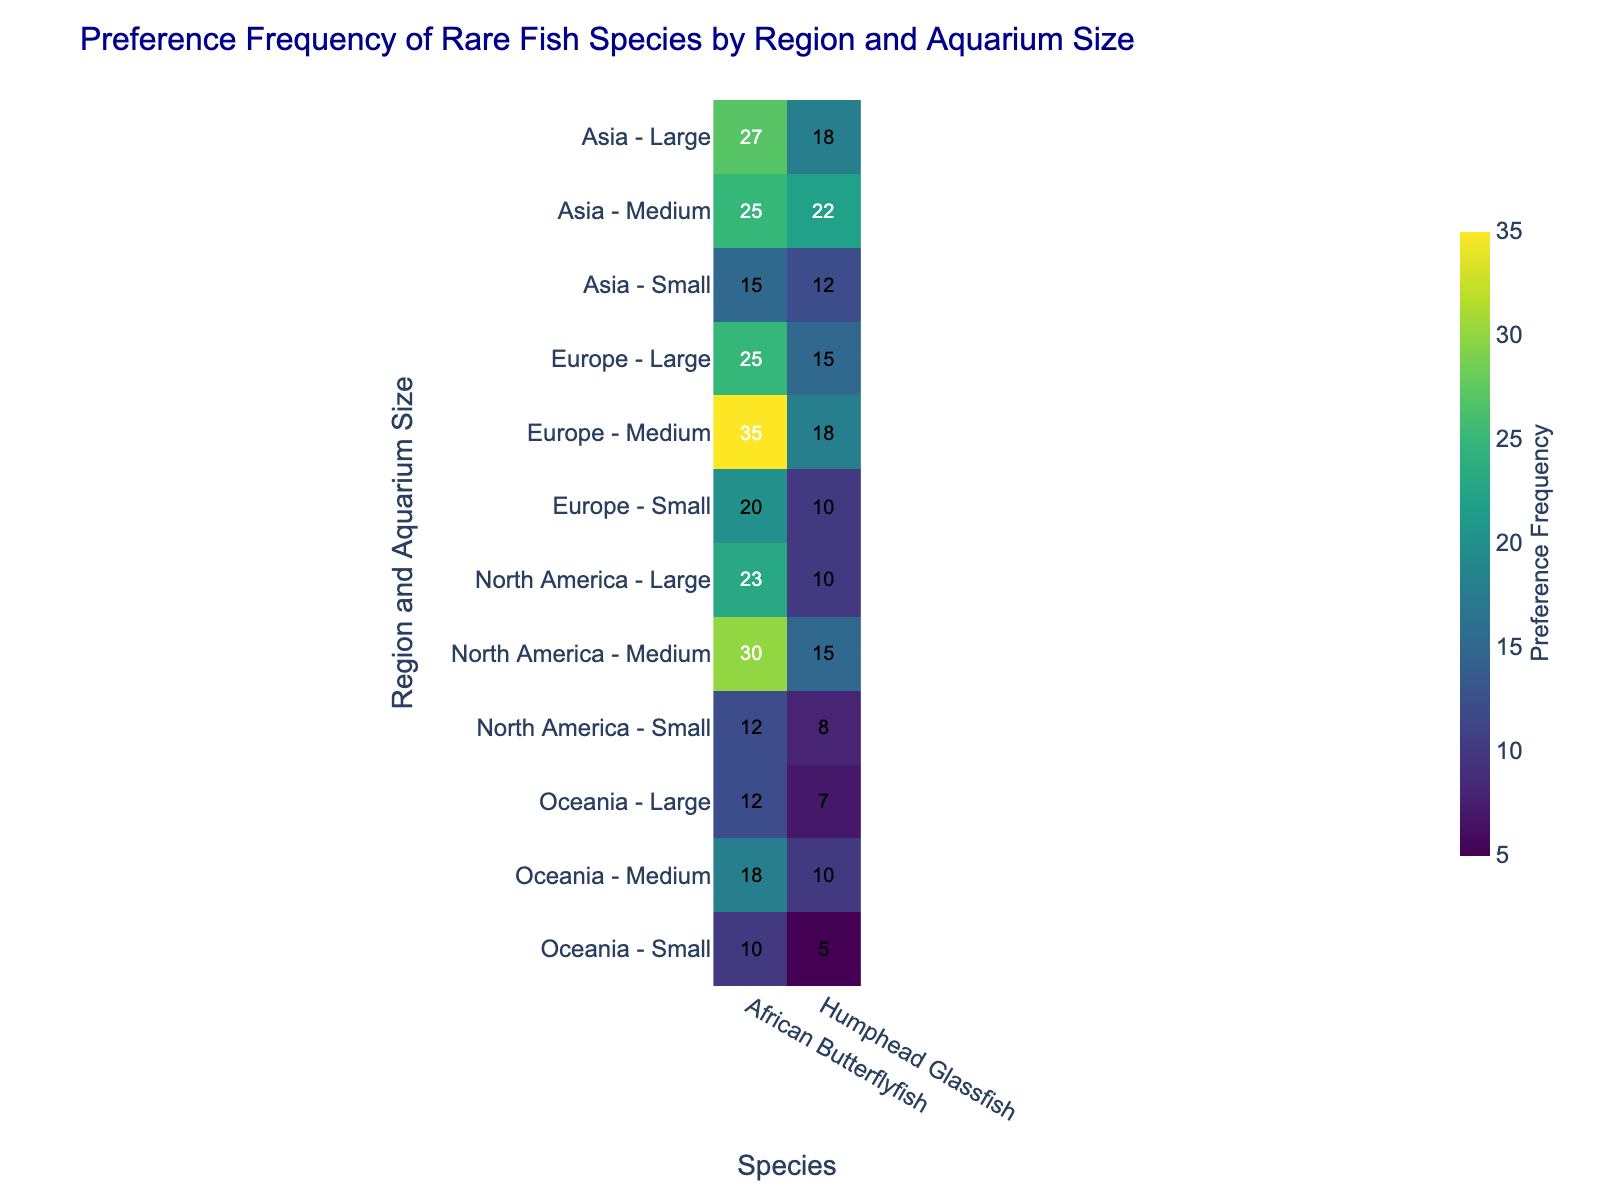What's the title of the figure? Look at the top of the figure where the title is usually placed.
Answer: "Preference Frequency of Rare Fish Species by Region and Aquarium Size" Which region has the highest preference frequency for African Butterflyfish in large aquariums? Identify the row labeled with each region and the column for African Butterflyfish, then find the highest number in the 'Large' category.
Answer: Asia How does the preference frequency for Humphead Glassfish in small aquariums in North America compare to that in Europe? Look at the intersections for North America and Europe in the 'Small' row and 'Humphead Glassfish' column, then compare their values. North America has a frequency of 8, and Europe has a frequency of 10.
Answer: Europe has a higher frequency What's the total preference frequency for African Butterflyfish in medium-sized aquariums across all regions? Add up the values in the 'Medium' row for African Butterflyfish across all regions: 30 (North America) + 35 (Europe) + 25 (Asia) + 18 (Oceania).
Answer: 108 Which region and aquarium size combination has the lowest preference frequency for Humphead Glassfish? Find the lowest value in the Humphead Glassfish column.
Answer: Oceania - Small Between Europe and Asia, which region shows a higher overall preference for African Butterflyfish? Sum the preference frequencies of African Butterflyfish in Europe and Asia across all aquarium sizes and compare: Europe (20+35+25) = 80, Asia (15+25+27) = 67.
Answer: Europe What is the average preference frequency for Humphead Glassfish in medium aquariums across all regions? Add the values for medium aquariums in the Humphead Glassfish column and divide by the number of regions: (15 + 18 + 22 + 10) / 4.
Answer: 16.25 How does the preference for African Butterflyfish in small aquariums in Oceania compare to that in North America? Compare the values in the 'Small' row for African Butterflyfish: Oceania (10) and North America (12).
Answer: North America has a higher preference Which aquarium size has the highest preference frequency for Humphead Glassfish in Asia? Compare the values for Humphead Glassfish in 'Small', 'Medium', and 'Large' aquarium sizes for Asia: Small (12), Medium (22), Large (18).
Answer: Medium What is the difference in preference frequency for African Butterflyfish between small and large aquariums in Europe? Subtract the preference frequency of African Butterflyfish in large aquariums from that in small aquariums in Europe: 25 (Large) - 20 (Small).
Answer: 5 